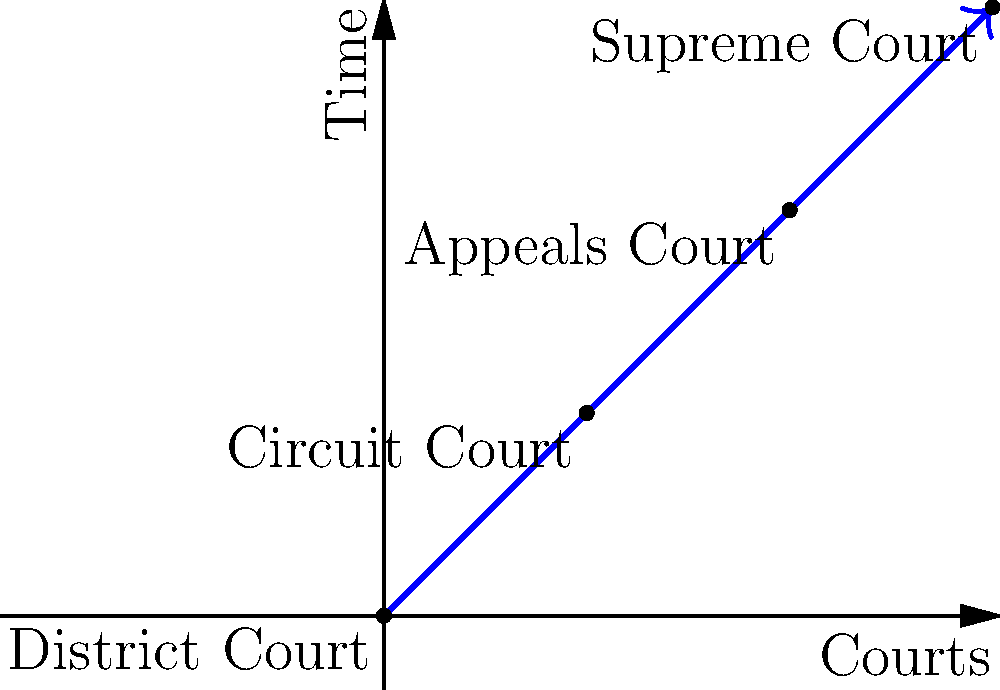Given the vector representation of a legal case's trajectory through various courts, what is the magnitude of the vector from the District Court to the Supreme Court, assuming each step between courts is represented by a unit vector $\vec{v} = (1,1)$? To solve this problem, we'll follow these steps:

1) First, we need to identify the vector from the District Court to the Supreme Court. From the diagram, we can see that this vector is the sum of three unit vectors, each representing a step between courts.

2) Each unit vector is given as $\vec{v} = (1,1)$. To find the total vector, we need to add these three times:

   $\vec{V} = 3\vec{v} = 3(1,1) = (3,3)$

3) Now that we have the total vector, we need to calculate its magnitude. The magnitude of a vector $(x,y)$ is given by the formula:

   $|\vec{V}| = \sqrt{x^2 + y^2}$

4) Substituting our values:

   $|\vec{V}| = \sqrt{3^2 + 3^2} = \sqrt{9 + 9} = \sqrt{18}$

5) Simplify:

   $|\vec{V}| = 3\sqrt{2}$

Therefore, the magnitude of the vector from the District Court to the Supreme Court is $3\sqrt{2}$.
Answer: $3\sqrt{2}$ 